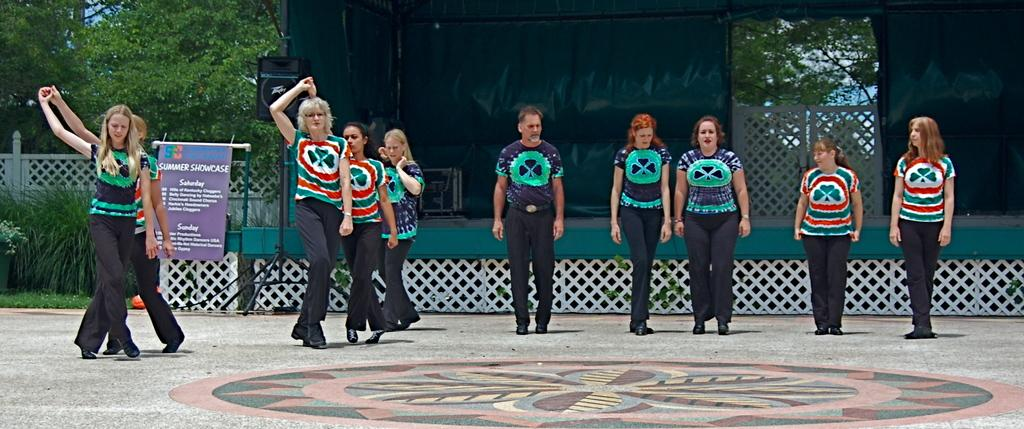What can be seen in the background of the image? There are trees and plants on the left side of the image. What is the main subject of the image? There are persons in front of the stage in the image. What object is present in the image that might be used for amplifying sound? There is a speaker in the image. What is hanging or attached to the stage in the image? There is a banner in the image. What type of advice can be heard coming from the airplane in the image? There is no airplane present in the image, so it's not possible to determine what, if any, advice might be heard. 